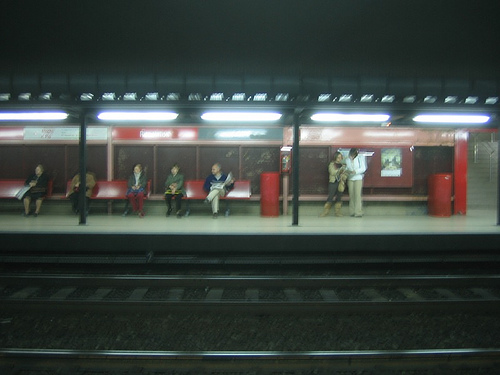<image>
Is the bench behind the man? No. The bench is not behind the man. From this viewpoint, the bench appears to be positioned elsewhere in the scene. 